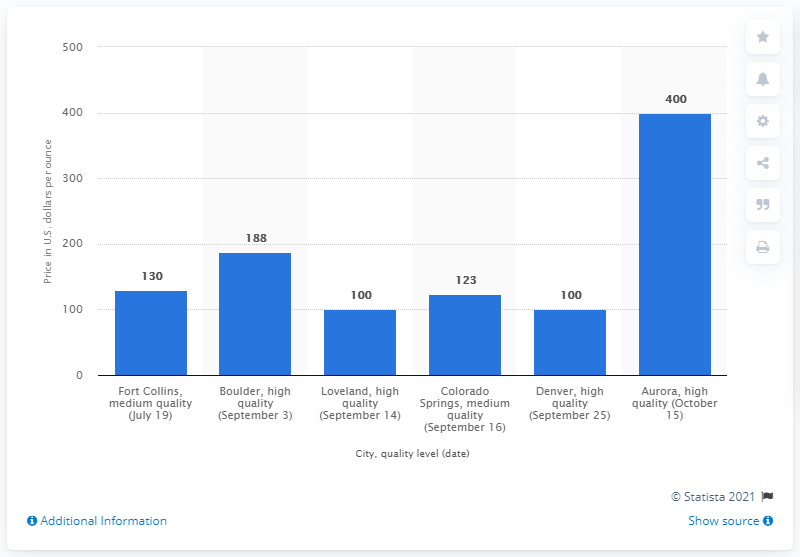Identify some key points in this picture. The average price per ounce of medium quality marijuana in Colorado Springs was 123. 